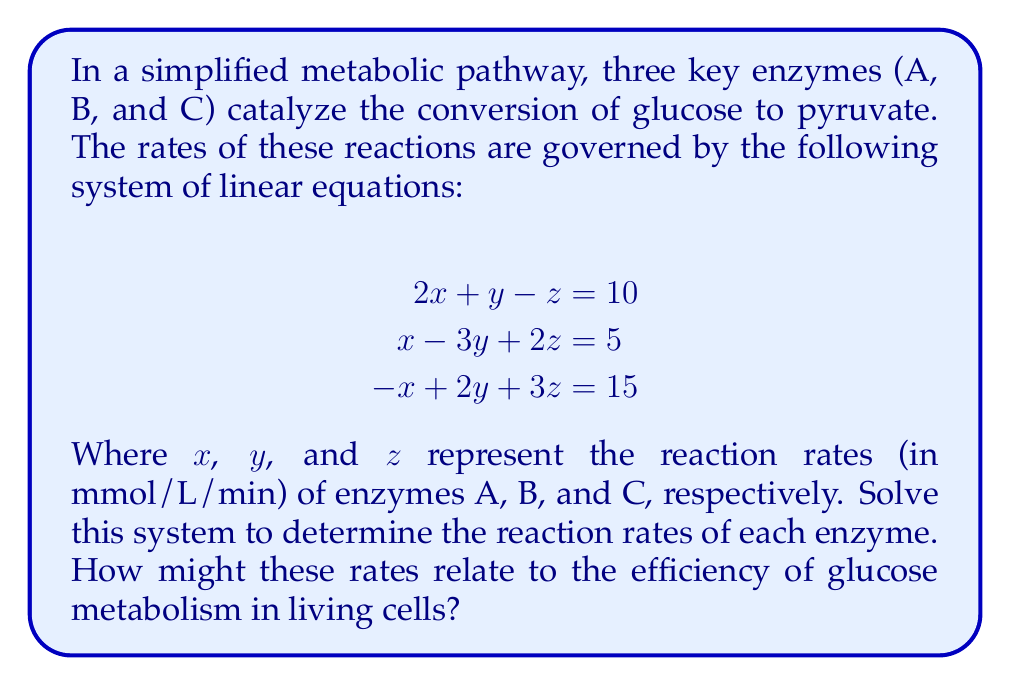Provide a solution to this math problem. To solve this system of linear equations, we'll use the Gaussian elimination method:

1) First, we'll write the augmented matrix:

$$\begin{bmatrix}
2 & 1 & -1 & 10 \\
1 & -3 & 2 & 5 \\
-1 & 2 & 3 & 15
\end{bmatrix}$$

2) Multiply the first row by -1/2 and add it to the second row:

$$\begin{bmatrix}
2 & 1 & -1 & 10 \\
0 & -3.5 & 2.5 & 0 \\
-1 & 2 & 3 & 15
\end{bmatrix}$$

3) Add the first row to the third row:

$$\begin{bmatrix}
2 & 1 & -1 & 10 \\
0 & -3.5 & 2.5 & 0 \\
1 & 3 & 2 & 25
\end{bmatrix}$$

4) Multiply the second row by 2/7 and add it to the third row:

$$\begin{bmatrix}
2 & 1 & -1 & 10 \\
0 & -3.5 & 2.5 & 0 \\
1 & 1 & 3 & 25
\end{bmatrix}$$

5) Subtract 1/2 of the third row from the first row:

$$\begin{bmatrix}
1.5 & 0.5 & -2.5 & -2.5 \\
0 & -3.5 & 2.5 & 0 \\
1 & 1 & 3 & 25
\end{bmatrix}$$

6) Now we have an upper triangular matrix. We can solve by back-substitution:

From the second row: $-3.5y + 2.5z = 0$
$y = \frac{5z}{7}$

From the third row: $x + y + 3z = 25$
Substituting $y$: $x + \frac{5z}{7} + 3z = 25$
$x + \frac{26z}{7} = 25$
$x = 25 - \frac{26z}{7}$

From the first row: $1.5x + 0.5y - 2.5z = -2.5$
Substituting $x$ and $y$:
$1.5(25 - \frac{26z}{7}) + 0.5(\frac{5z}{7}) - 2.5z = -2.5$

Solving this equation gives us $z = 5$.

Substituting back, we get $y = \frac{25}{7}$ and $x = \frac{45}{7}$.

These rates indicate the relative activity of each enzyme in the pathway. Enzyme A (x) has the highest rate, followed by enzyme C (z), and then enzyme B (y). This suggests that enzyme A might be the rate-limiting step in this simplified pathway. In living cells, such differences in enzyme rates could influence the overall efficiency of glucose metabolism, potentially affecting energy production and cellular function.
Answer: $x = \frac{45}{7}$, $y = \frac{25}{7}$, $z = 5$ 